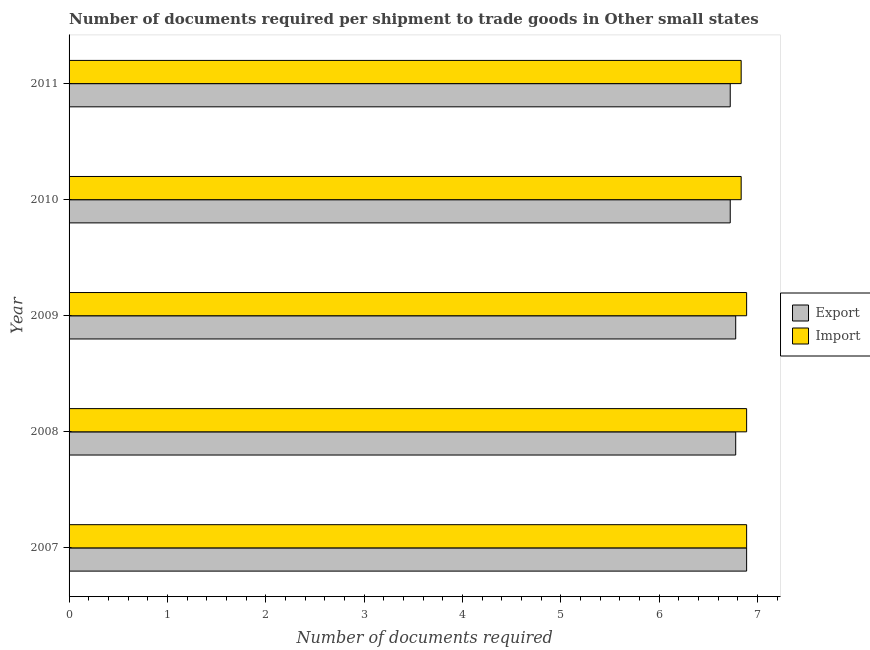How many different coloured bars are there?
Your answer should be very brief. 2. How many bars are there on the 2nd tick from the bottom?
Ensure brevity in your answer.  2. What is the label of the 2nd group of bars from the top?
Provide a short and direct response. 2010. What is the number of documents required to export goods in 2007?
Provide a succinct answer. 6.89. Across all years, what is the maximum number of documents required to export goods?
Offer a terse response. 6.89. Across all years, what is the minimum number of documents required to export goods?
Give a very brief answer. 6.72. In which year was the number of documents required to import goods minimum?
Your answer should be compact. 2010. What is the total number of documents required to export goods in the graph?
Your response must be concise. 33.89. What is the difference between the number of documents required to export goods in 2009 and that in 2011?
Ensure brevity in your answer.  0.06. What is the difference between the number of documents required to export goods in 2009 and the number of documents required to import goods in 2010?
Your answer should be very brief. -0.06. What is the average number of documents required to import goods per year?
Give a very brief answer. 6.87. In the year 2009, what is the difference between the number of documents required to import goods and number of documents required to export goods?
Offer a very short reply. 0.11. Is the number of documents required to export goods in 2007 less than that in 2008?
Offer a terse response. No. Is the difference between the number of documents required to export goods in 2009 and 2011 greater than the difference between the number of documents required to import goods in 2009 and 2011?
Provide a short and direct response. Yes. What is the difference between the highest and the lowest number of documents required to export goods?
Provide a short and direct response. 0.17. In how many years, is the number of documents required to import goods greater than the average number of documents required to import goods taken over all years?
Your answer should be compact. 3. What does the 2nd bar from the top in 2007 represents?
Offer a very short reply. Export. What does the 1st bar from the bottom in 2007 represents?
Keep it short and to the point. Export. How many years are there in the graph?
Your answer should be very brief. 5. Are the values on the major ticks of X-axis written in scientific E-notation?
Your answer should be very brief. No. What is the title of the graph?
Make the answer very short. Number of documents required per shipment to trade goods in Other small states. Does "Passenger Transport Items" appear as one of the legend labels in the graph?
Your answer should be very brief. No. What is the label or title of the X-axis?
Your response must be concise. Number of documents required. What is the label or title of the Y-axis?
Your answer should be very brief. Year. What is the Number of documents required in Export in 2007?
Make the answer very short. 6.89. What is the Number of documents required of Import in 2007?
Provide a succinct answer. 6.89. What is the Number of documents required in Export in 2008?
Keep it short and to the point. 6.78. What is the Number of documents required of Import in 2008?
Make the answer very short. 6.89. What is the Number of documents required of Export in 2009?
Provide a short and direct response. 6.78. What is the Number of documents required in Import in 2009?
Make the answer very short. 6.89. What is the Number of documents required in Export in 2010?
Provide a short and direct response. 6.72. What is the Number of documents required of Import in 2010?
Offer a terse response. 6.83. What is the Number of documents required in Export in 2011?
Provide a succinct answer. 6.72. What is the Number of documents required of Import in 2011?
Your answer should be very brief. 6.83. Across all years, what is the maximum Number of documents required in Export?
Ensure brevity in your answer.  6.89. Across all years, what is the maximum Number of documents required of Import?
Offer a terse response. 6.89. Across all years, what is the minimum Number of documents required in Export?
Your answer should be very brief. 6.72. Across all years, what is the minimum Number of documents required of Import?
Provide a short and direct response. 6.83. What is the total Number of documents required of Export in the graph?
Ensure brevity in your answer.  33.89. What is the total Number of documents required of Import in the graph?
Your response must be concise. 34.33. What is the difference between the Number of documents required in Export in 2007 and that in 2008?
Ensure brevity in your answer.  0.11. What is the difference between the Number of documents required of Import in 2007 and that in 2009?
Make the answer very short. 0. What is the difference between the Number of documents required in Export in 2007 and that in 2010?
Offer a very short reply. 0.17. What is the difference between the Number of documents required of Import in 2007 and that in 2010?
Your answer should be very brief. 0.06. What is the difference between the Number of documents required of Import in 2007 and that in 2011?
Provide a short and direct response. 0.06. What is the difference between the Number of documents required in Export in 2008 and that in 2009?
Offer a very short reply. 0. What is the difference between the Number of documents required of Import in 2008 and that in 2009?
Ensure brevity in your answer.  0. What is the difference between the Number of documents required of Export in 2008 and that in 2010?
Your answer should be very brief. 0.06. What is the difference between the Number of documents required of Import in 2008 and that in 2010?
Your answer should be compact. 0.06. What is the difference between the Number of documents required of Export in 2008 and that in 2011?
Offer a terse response. 0.06. What is the difference between the Number of documents required in Import in 2008 and that in 2011?
Your answer should be very brief. 0.06. What is the difference between the Number of documents required in Export in 2009 and that in 2010?
Provide a succinct answer. 0.06. What is the difference between the Number of documents required in Import in 2009 and that in 2010?
Your response must be concise. 0.06. What is the difference between the Number of documents required in Export in 2009 and that in 2011?
Provide a short and direct response. 0.06. What is the difference between the Number of documents required of Import in 2009 and that in 2011?
Keep it short and to the point. 0.06. What is the difference between the Number of documents required in Import in 2010 and that in 2011?
Provide a succinct answer. 0. What is the difference between the Number of documents required in Export in 2007 and the Number of documents required in Import in 2010?
Your answer should be compact. 0.06. What is the difference between the Number of documents required of Export in 2007 and the Number of documents required of Import in 2011?
Keep it short and to the point. 0.06. What is the difference between the Number of documents required of Export in 2008 and the Number of documents required of Import in 2009?
Offer a very short reply. -0.11. What is the difference between the Number of documents required of Export in 2008 and the Number of documents required of Import in 2010?
Keep it short and to the point. -0.06. What is the difference between the Number of documents required of Export in 2008 and the Number of documents required of Import in 2011?
Your answer should be compact. -0.06. What is the difference between the Number of documents required of Export in 2009 and the Number of documents required of Import in 2010?
Offer a very short reply. -0.06. What is the difference between the Number of documents required of Export in 2009 and the Number of documents required of Import in 2011?
Make the answer very short. -0.06. What is the difference between the Number of documents required of Export in 2010 and the Number of documents required of Import in 2011?
Your answer should be very brief. -0.11. What is the average Number of documents required of Export per year?
Provide a succinct answer. 6.78. What is the average Number of documents required in Import per year?
Give a very brief answer. 6.87. In the year 2007, what is the difference between the Number of documents required of Export and Number of documents required of Import?
Provide a succinct answer. 0. In the year 2008, what is the difference between the Number of documents required of Export and Number of documents required of Import?
Your response must be concise. -0.11. In the year 2009, what is the difference between the Number of documents required of Export and Number of documents required of Import?
Provide a succinct answer. -0.11. In the year 2010, what is the difference between the Number of documents required of Export and Number of documents required of Import?
Your answer should be very brief. -0.11. In the year 2011, what is the difference between the Number of documents required in Export and Number of documents required in Import?
Your answer should be very brief. -0.11. What is the ratio of the Number of documents required of Export in 2007 to that in 2008?
Provide a short and direct response. 1.02. What is the ratio of the Number of documents required of Export in 2007 to that in 2009?
Make the answer very short. 1.02. What is the ratio of the Number of documents required of Import in 2007 to that in 2009?
Provide a succinct answer. 1. What is the ratio of the Number of documents required in Export in 2007 to that in 2010?
Keep it short and to the point. 1.02. What is the ratio of the Number of documents required of Import in 2007 to that in 2010?
Keep it short and to the point. 1.01. What is the ratio of the Number of documents required in Export in 2007 to that in 2011?
Your answer should be compact. 1.02. What is the ratio of the Number of documents required in Import in 2007 to that in 2011?
Provide a succinct answer. 1.01. What is the ratio of the Number of documents required in Export in 2008 to that in 2010?
Offer a very short reply. 1.01. What is the ratio of the Number of documents required of Export in 2008 to that in 2011?
Make the answer very short. 1.01. What is the ratio of the Number of documents required of Export in 2009 to that in 2010?
Offer a terse response. 1.01. What is the ratio of the Number of documents required in Export in 2009 to that in 2011?
Your answer should be compact. 1.01. What is the ratio of the Number of documents required of Import in 2009 to that in 2011?
Your answer should be very brief. 1.01. What is the ratio of the Number of documents required in Export in 2010 to that in 2011?
Ensure brevity in your answer.  1. What is the ratio of the Number of documents required in Import in 2010 to that in 2011?
Give a very brief answer. 1. What is the difference between the highest and the second highest Number of documents required of Import?
Provide a short and direct response. 0. What is the difference between the highest and the lowest Number of documents required of Export?
Provide a succinct answer. 0.17. What is the difference between the highest and the lowest Number of documents required in Import?
Give a very brief answer. 0.06. 